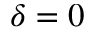Convert formula to latex. <formula><loc_0><loc_0><loc_500><loc_500>\delta = 0</formula> 